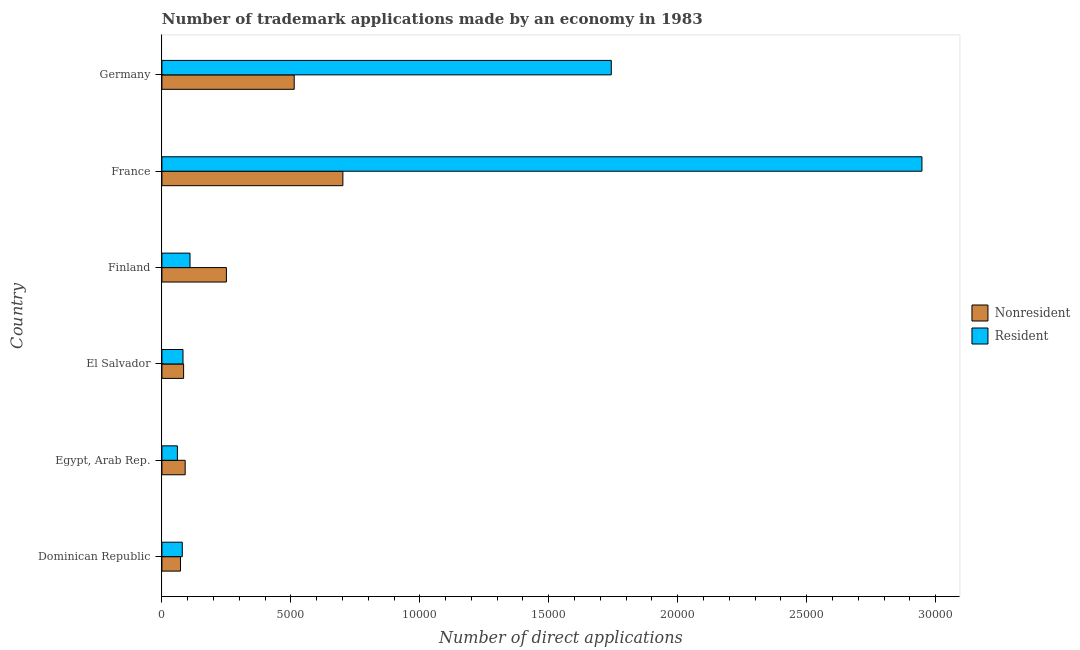How many groups of bars are there?
Your response must be concise. 6. Are the number of bars per tick equal to the number of legend labels?
Your answer should be very brief. Yes. How many bars are there on the 4th tick from the top?
Provide a short and direct response. 2. How many bars are there on the 5th tick from the bottom?
Ensure brevity in your answer.  2. What is the label of the 4th group of bars from the top?
Keep it short and to the point. El Salvador. What is the number of trademark applications made by residents in El Salvador?
Make the answer very short. 818. Across all countries, what is the maximum number of trademark applications made by residents?
Provide a succinct answer. 2.95e+04. Across all countries, what is the minimum number of trademark applications made by residents?
Give a very brief answer. 600. In which country was the number of trademark applications made by non residents minimum?
Your answer should be very brief. Dominican Republic. What is the total number of trademark applications made by residents in the graph?
Offer a terse response. 5.02e+04. What is the difference between the number of trademark applications made by residents in Finland and that in Germany?
Keep it short and to the point. -1.63e+04. What is the difference between the number of trademark applications made by residents in Finland and the number of trademark applications made by non residents in Germany?
Your answer should be very brief. -4040. What is the average number of trademark applications made by residents per country?
Your response must be concise. 8365.17. What is the difference between the number of trademark applications made by non residents and number of trademark applications made by residents in Egypt, Arab Rep.?
Provide a succinct answer. 302. What is the ratio of the number of trademark applications made by residents in Egypt, Arab Rep. to that in Germany?
Provide a succinct answer. 0.03. What is the difference between the highest and the second highest number of trademark applications made by non residents?
Your response must be concise. 1887. What is the difference between the highest and the lowest number of trademark applications made by residents?
Provide a succinct answer. 2.89e+04. What does the 1st bar from the top in Finland represents?
Your response must be concise. Resident. What does the 1st bar from the bottom in France represents?
Ensure brevity in your answer.  Nonresident. What is the difference between two consecutive major ticks on the X-axis?
Make the answer very short. 5000. Are the values on the major ticks of X-axis written in scientific E-notation?
Provide a short and direct response. No. Does the graph contain any zero values?
Provide a succinct answer. No. Does the graph contain grids?
Ensure brevity in your answer.  No. Where does the legend appear in the graph?
Provide a succinct answer. Center right. How many legend labels are there?
Your response must be concise. 2. How are the legend labels stacked?
Your answer should be very brief. Vertical. What is the title of the graph?
Your response must be concise. Number of trademark applications made by an economy in 1983. Does "Male entrants" appear as one of the legend labels in the graph?
Provide a short and direct response. No. What is the label or title of the X-axis?
Offer a terse response. Number of direct applications. What is the label or title of the Y-axis?
Your response must be concise. Country. What is the Number of direct applications in Nonresident in Dominican Republic?
Keep it short and to the point. 722. What is the Number of direct applications in Resident in Dominican Republic?
Offer a terse response. 790. What is the Number of direct applications of Nonresident in Egypt, Arab Rep.?
Ensure brevity in your answer.  902. What is the Number of direct applications of Resident in Egypt, Arab Rep.?
Your answer should be very brief. 600. What is the Number of direct applications in Nonresident in El Salvador?
Your response must be concise. 842. What is the Number of direct applications in Resident in El Salvador?
Provide a succinct answer. 818. What is the Number of direct applications in Nonresident in Finland?
Make the answer very short. 2501. What is the Number of direct applications in Resident in Finland?
Your answer should be very brief. 1090. What is the Number of direct applications in Nonresident in France?
Offer a very short reply. 7017. What is the Number of direct applications of Resident in France?
Your answer should be very brief. 2.95e+04. What is the Number of direct applications in Nonresident in Germany?
Provide a succinct answer. 5130. What is the Number of direct applications in Resident in Germany?
Ensure brevity in your answer.  1.74e+04. Across all countries, what is the maximum Number of direct applications in Nonresident?
Make the answer very short. 7017. Across all countries, what is the maximum Number of direct applications of Resident?
Offer a terse response. 2.95e+04. Across all countries, what is the minimum Number of direct applications of Nonresident?
Your answer should be compact. 722. Across all countries, what is the minimum Number of direct applications of Resident?
Keep it short and to the point. 600. What is the total Number of direct applications of Nonresident in the graph?
Give a very brief answer. 1.71e+04. What is the total Number of direct applications of Resident in the graph?
Keep it short and to the point. 5.02e+04. What is the difference between the Number of direct applications in Nonresident in Dominican Republic and that in Egypt, Arab Rep.?
Offer a terse response. -180. What is the difference between the Number of direct applications of Resident in Dominican Republic and that in Egypt, Arab Rep.?
Provide a short and direct response. 190. What is the difference between the Number of direct applications of Nonresident in Dominican Republic and that in El Salvador?
Provide a short and direct response. -120. What is the difference between the Number of direct applications in Resident in Dominican Republic and that in El Salvador?
Your response must be concise. -28. What is the difference between the Number of direct applications in Nonresident in Dominican Republic and that in Finland?
Offer a terse response. -1779. What is the difference between the Number of direct applications of Resident in Dominican Republic and that in Finland?
Provide a succinct answer. -300. What is the difference between the Number of direct applications in Nonresident in Dominican Republic and that in France?
Your answer should be compact. -6295. What is the difference between the Number of direct applications of Resident in Dominican Republic and that in France?
Provide a short and direct response. -2.87e+04. What is the difference between the Number of direct applications in Nonresident in Dominican Republic and that in Germany?
Give a very brief answer. -4408. What is the difference between the Number of direct applications of Resident in Dominican Republic and that in Germany?
Your response must be concise. -1.66e+04. What is the difference between the Number of direct applications in Resident in Egypt, Arab Rep. and that in El Salvador?
Provide a short and direct response. -218. What is the difference between the Number of direct applications of Nonresident in Egypt, Arab Rep. and that in Finland?
Your answer should be very brief. -1599. What is the difference between the Number of direct applications of Resident in Egypt, Arab Rep. and that in Finland?
Make the answer very short. -490. What is the difference between the Number of direct applications in Nonresident in Egypt, Arab Rep. and that in France?
Provide a succinct answer. -6115. What is the difference between the Number of direct applications of Resident in Egypt, Arab Rep. and that in France?
Offer a very short reply. -2.89e+04. What is the difference between the Number of direct applications of Nonresident in Egypt, Arab Rep. and that in Germany?
Offer a very short reply. -4228. What is the difference between the Number of direct applications in Resident in Egypt, Arab Rep. and that in Germany?
Offer a terse response. -1.68e+04. What is the difference between the Number of direct applications of Nonresident in El Salvador and that in Finland?
Offer a terse response. -1659. What is the difference between the Number of direct applications of Resident in El Salvador and that in Finland?
Keep it short and to the point. -272. What is the difference between the Number of direct applications of Nonresident in El Salvador and that in France?
Your answer should be compact. -6175. What is the difference between the Number of direct applications in Resident in El Salvador and that in France?
Your response must be concise. -2.87e+04. What is the difference between the Number of direct applications of Nonresident in El Salvador and that in Germany?
Give a very brief answer. -4288. What is the difference between the Number of direct applications of Resident in El Salvador and that in Germany?
Make the answer very short. -1.66e+04. What is the difference between the Number of direct applications in Nonresident in Finland and that in France?
Provide a short and direct response. -4516. What is the difference between the Number of direct applications of Resident in Finland and that in France?
Your answer should be very brief. -2.84e+04. What is the difference between the Number of direct applications in Nonresident in Finland and that in Germany?
Offer a very short reply. -2629. What is the difference between the Number of direct applications in Resident in Finland and that in Germany?
Offer a terse response. -1.63e+04. What is the difference between the Number of direct applications of Nonresident in France and that in Germany?
Ensure brevity in your answer.  1887. What is the difference between the Number of direct applications in Resident in France and that in Germany?
Provide a succinct answer. 1.20e+04. What is the difference between the Number of direct applications in Nonresident in Dominican Republic and the Number of direct applications in Resident in Egypt, Arab Rep.?
Keep it short and to the point. 122. What is the difference between the Number of direct applications of Nonresident in Dominican Republic and the Number of direct applications of Resident in El Salvador?
Your response must be concise. -96. What is the difference between the Number of direct applications in Nonresident in Dominican Republic and the Number of direct applications in Resident in Finland?
Your answer should be compact. -368. What is the difference between the Number of direct applications of Nonresident in Dominican Republic and the Number of direct applications of Resident in France?
Offer a very short reply. -2.87e+04. What is the difference between the Number of direct applications of Nonresident in Dominican Republic and the Number of direct applications of Resident in Germany?
Your response must be concise. -1.67e+04. What is the difference between the Number of direct applications of Nonresident in Egypt, Arab Rep. and the Number of direct applications of Resident in Finland?
Make the answer very short. -188. What is the difference between the Number of direct applications in Nonresident in Egypt, Arab Rep. and the Number of direct applications in Resident in France?
Provide a short and direct response. -2.86e+04. What is the difference between the Number of direct applications of Nonresident in Egypt, Arab Rep. and the Number of direct applications of Resident in Germany?
Give a very brief answer. -1.65e+04. What is the difference between the Number of direct applications in Nonresident in El Salvador and the Number of direct applications in Resident in Finland?
Provide a succinct answer. -248. What is the difference between the Number of direct applications of Nonresident in El Salvador and the Number of direct applications of Resident in France?
Make the answer very short. -2.86e+04. What is the difference between the Number of direct applications in Nonresident in El Salvador and the Number of direct applications in Resident in Germany?
Offer a very short reply. -1.66e+04. What is the difference between the Number of direct applications of Nonresident in Finland and the Number of direct applications of Resident in France?
Your response must be concise. -2.70e+04. What is the difference between the Number of direct applications in Nonresident in Finland and the Number of direct applications in Resident in Germany?
Give a very brief answer. -1.49e+04. What is the difference between the Number of direct applications in Nonresident in France and the Number of direct applications in Resident in Germany?
Offer a very short reply. -1.04e+04. What is the average Number of direct applications of Nonresident per country?
Your answer should be very brief. 2852.33. What is the average Number of direct applications in Resident per country?
Your response must be concise. 8365.17. What is the difference between the Number of direct applications of Nonresident and Number of direct applications of Resident in Dominican Republic?
Provide a succinct answer. -68. What is the difference between the Number of direct applications in Nonresident and Number of direct applications in Resident in Egypt, Arab Rep.?
Give a very brief answer. 302. What is the difference between the Number of direct applications in Nonresident and Number of direct applications in Resident in Finland?
Offer a very short reply. 1411. What is the difference between the Number of direct applications of Nonresident and Number of direct applications of Resident in France?
Your answer should be very brief. -2.25e+04. What is the difference between the Number of direct applications in Nonresident and Number of direct applications in Resident in Germany?
Keep it short and to the point. -1.23e+04. What is the ratio of the Number of direct applications in Nonresident in Dominican Republic to that in Egypt, Arab Rep.?
Offer a terse response. 0.8. What is the ratio of the Number of direct applications of Resident in Dominican Republic to that in Egypt, Arab Rep.?
Keep it short and to the point. 1.32. What is the ratio of the Number of direct applications in Nonresident in Dominican Republic to that in El Salvador?
Ensure brevity in your answer.  0.86. What is the ratio of the Number of direct applications of Resident in Dominican Republic to that in El Salvador?
Your answer should be very brief. 0.97. What is the ratio of the Number of direct applications of Nonresident in Dominican Republic to that in Finland?
Provide a short and direct response. 0.29. What is the ratio of the Number of direct applications in Resident in Dominican Republic to that in Finland?
Give a very brief answer. 0.72. What is the ratio of the Number of direct applications of Nonresident in Dominican Republic to that in France?
Provide a succinct answer. 0.1. What is the ratio of the Number of direct applications of Resident in Dominican Republic to that in France?
Offer a very short reply. 0.03. What is the ratio of the Number of direct applications in Nonresident in Dominican Republic to that in Germany?
Provide a short and direct response. 0.14. What is the ratio of the Number of direct applications of Resident in Dominican Republic to that in Germany?
Ensure brevity in your answer.  0.05. What is the ratio of the Number of direct applications in Nonresident in Egypt, Arab Rep. to that in El Salvador?
Make the answer very short. 1.07. What is the ratio of the Number of direct applications of Resident in Egypt, Arab Rep. to that in El Salvador?
Offer a very short reply. 0.73. What is the ratio of the Number of direct applications of Nonresident in Egypt, Arab Rep. to that in Finland?
Provide a succinct answer. 0.36. What is the ratio of the Number of direct applications of Resident in Egypt, Arab Rep. to that in Finland?
Give a very brief answer. 0.55. What is the ratio of the Number of direct applications of Nonresident in Egypt, Arab Rep. to that in France?
Make the answer very short. 0.13. What is the ratio of the Number of direct applications of Resident in Egypt, Arab Rep. to that in France?
Make the answer very short. 0.02. What is the ratio of the Number of direct applications of Nonresident in Egypt, Arab Rep. to that in Germany?
Your answer should be compact. 0.18. What is the ratio of the Number of direct applications in Resident in Egypt, Arab Rep. to that in Germany?
Give a very brief answer. 0.03. What is the ratio of the Number of direct applications in Nonresident in El Salvador to that in Finland?
Your response must be concise. 0.34. What is the ratio of the Number of direct applications in Resident in El Salvador to that in Finland?
Make the answer very short. 0.75. What is the ratio of the Number of direct applications in Nonresident in El Salvador to that in France?
Your answer should be compact. 0.12. What is the ratio of the Number of direct applications of Resident in El Salvador to that in France?
Give a very brief answer. 0.03. What is the ratio of the Number of direct applications in Nonresident in El Salvador to that in Germany?
Ensure brevity in your answer.  0.16. What is the ratio of the Number of direct applications of Resident in El Salvador to that in Germany?
Make the answer very short. 0.05. What is the ratio of the Number of direct applications of Nonresident in Finland to that in France?
Your answer should be very brief. 0.36. What is the ratio of the Number of direct applications in Resident in Finland to that in France?
Offer a very short reply. 0.04. What is the ratio of the Number of direct applications in Nonresident in Finland to that in Germany?
Provide a short and direct response. 0.49. What is the ratio of the Number of direct applications of Resident in Finland to that in Germany?
Offer a very short reply. 0.06. What is the ratio of the Number of direct applications of Nonresident in France to that in Germany?
Provide a short and direct response. 1.37. What is the ratio of the Number of direct applications of Resident in France to that in Germany?
Give a very brief answer. 1.69. What is the difference between the highest and the second highest Number of direct applications in Nonresident?
Ensure brevity in your answer.  1887. What is the difference between the highest and the second highest Number of direct applications of Resident?
Make the answer very short. 1.20e+04. What is the difference between the highest and the lowest Number of direct applications of Nonresident?
Your answer should be compact. 6295. What is the difference between the highest and the lowest Number of direct applications in Resident?
Keep it short and to the point. 2.89e+04. 